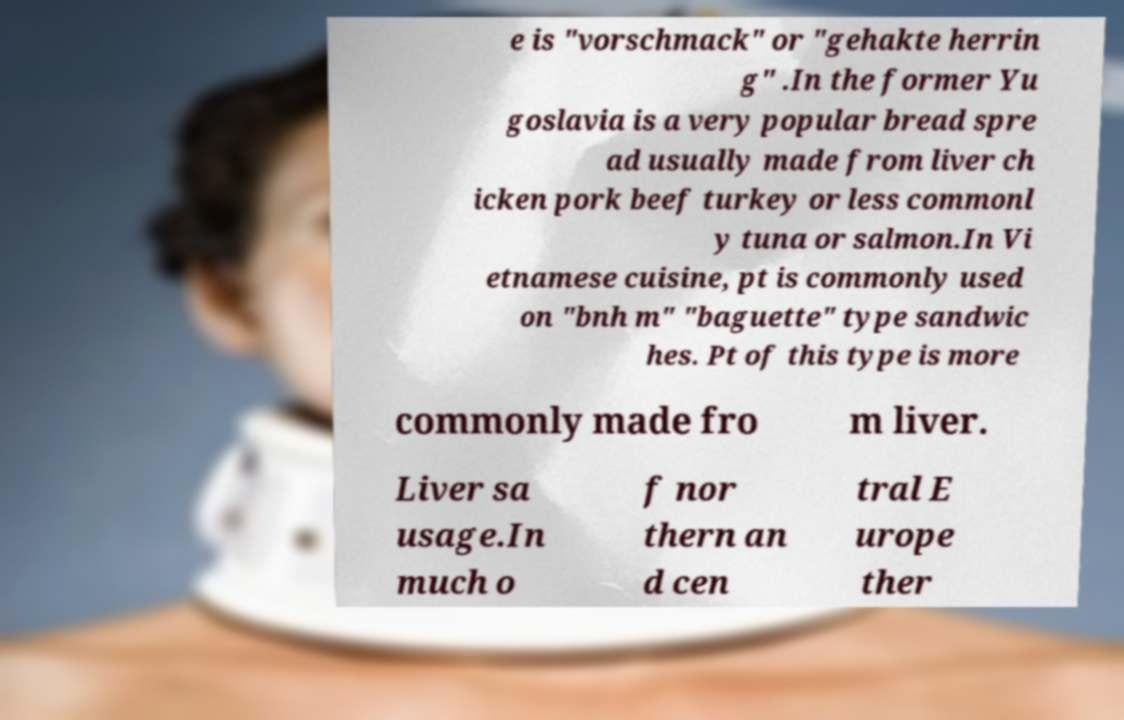I need the written content from this picture converted into text. Can you do that? e is "vorschmack" or "gehakte herrin g" .In the former Yu goslavia is a very popular bread spre ad usually made from liver ch icken pork beef turkey or less commonl y tuna or salmon.In Vi etnamese cuisine, pt is commonly used on "bnh m" "baguette" type sandwic hes. Pt of this type is more commonly made fro m liver. Liver sa usage.In much o f nor thern an d cen tral E urope ther 